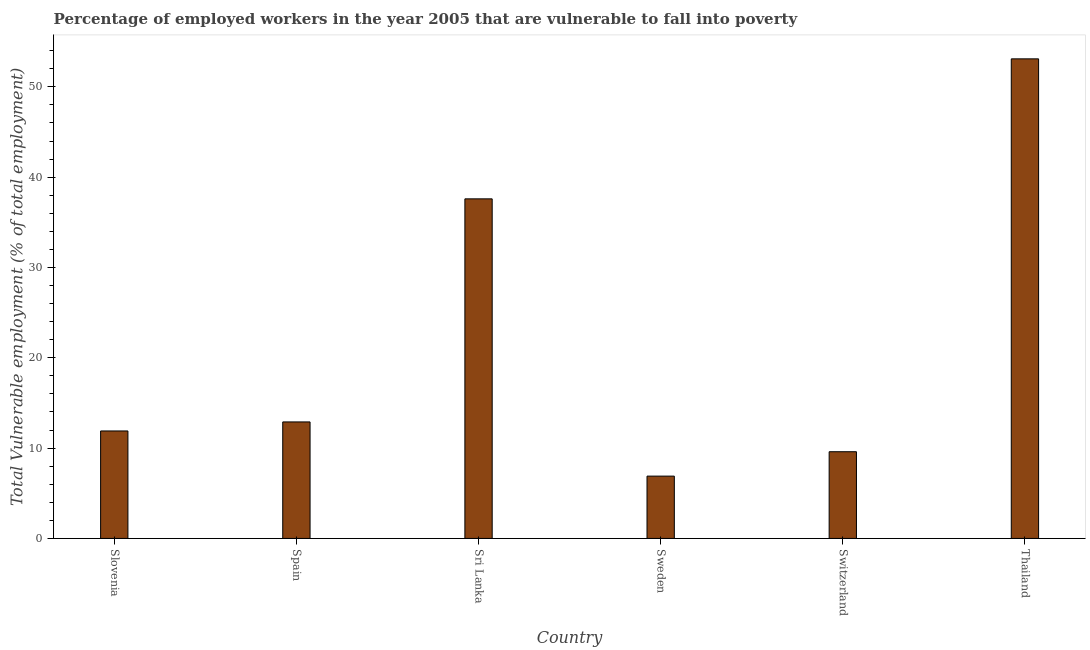Does the graph contain any zero values?
Offer a terse response. No. What is the title of the graph?
Give a very brief answer. Percentage of employed workers in the year 2005 that are vulnerable to fall into poverty. What is the label or title of the X-axis?
Provide a succinct answer. Country. What is the label or title of the Y-axis?
Offer a terse response. Total Vulnerable employment (% of total employment). What is the total vulnerable employment in Sweden?
Your answer should be very brief. 6.9. Across all countries, what is the maximum total vulnerable employment?
Keep it short and to the point. 53.1. Across all countries, what is the minimum total vulnerable employment?
Offer a very short reply. 6.9. In which country was the total vulnerable employment maximum?
Offer a very short reply. Thailand. In which country was the total vulnerable employment minimum?
Make the answer very short. Sweden. What is the sum of the total vulnerable employment?
Make the answer very short. 132. What is the difference between the total vulnerable employment in Slovenia and Spain?
Give a very brief answer. -1. What is the median total vulnerable employment?
Your answer should be very brief. 12.4. In how many countries, is the total vulnerable employment greater than 18 %?
Ensure brevity in your answer.  2. What is the ratio of the total vulnerable employment in Sweden to that in Switzerland?
Give a very brief answer. 0.72. Is the total vulnerable employment in Slovenia less than that in Sri Lanka?
Offer a very short reply. Yes. Is the difference between the total vulnerable employment in Spain and Sweden greater than the difference between any two countries?
Keep it short and to the point. No. Is the sum of the total vulnerable employment in Slovenia and Switzerland greater than the maximum total vulnerable employment across all countries?
Offer a terse response. No. What is the difference between the highest and the lowest total vulnerable employment?
Provide a succinct answer. 46.2. In how many countries, is the total vulnerable employment greater than the average total vulnerable employment taken over all countries?
Keep it short and to the point. 2. How many bars are there?
Give a very brief answer. 6. Are all the bars in the graph horizontal?
Offer a terse response. No. What is the Total Vulnerable employment (% of total employment) in Slovenia?
Give a very brief answer. 11.9. What is the Total Vulnerable employment (% of total employment) in Spain?
Ensure brevity in your answer.  12.9. What is the Total Vulnerable employment (% of total employment) in Sri Lanka?
Provide a succinct answer. 37.6. What is the Total Vulnerable employment (% of total employment) in Sweden?
Your response must be concise. 6.9. What is the Total Vulnerable employment (% of total employment) of Switzerland?
Provide a succinct answer. 9.6. What is the Total Vulnerable employment (% of total employment) of Thailand?
Make the answer very short. 53.1. What is the difference between the Total Vulnerable employment (% of total employment) in Slovenia and Spain?
Your answer should be compact. -1. What is the difference between the Total Vulnerable employment (% of total employment) in Slovenia and Sri Lanka?
Your response must be concise. -25.7. What is the difference between the Total Vulnerable employment (% of total employment) in Slovenia and Switzerland?
Your answer should be compact. 2.3. What is the difference between the Total Vulnerable employment (% of total employment) in Slovenia and Thailand?
Your answer should be compact. -41.2. What is the difference between the Total Vulnerable employment (% of total employment) in Spain and Sri Lanka?
Give a very brief answer. -24.7. What is the difference between the Total Vulnerable employment (% of total employment) in Spain and Sweden?
Offer a terse response. 6. What is the difference between the Total Vulnerable employment (% of total employment) in Spain and Switzerland?
Provide a succinct answer. 3.3. What is the difference between the Total Vulnerable employment (% of total employment) in Spain and Thailand?
Offer a terse response. -40.2. What is the difference between the Total Vulnerable employment (% of total employment) in Sri Lanka and Sweden?
Ensure brevity in your answer.  30.7. What is the difference between the Total Vulnerable employment (% of total employment) in Sri Lanka and Switzerland?
Your answer should be very brief. 28. What is the difference between the Total Vulnerable employment (% of total employment) in Sri Lanka and Thailand?
Your answer should be very brief. -15.5. What is the difference between the Total Vulnerable employment (% of total employment) in Sweden and Thailand?
Make the answer very short. -46.2. What is the difference between the Total Vulnerable employment (% of total employment) in Switzerland and Thailand?
Keep it short and to the point. -43.5. What is the ratio of the Total Vulnerable employment (% of total employment) in Slovenia to that in Spain?
Offer a terse response. 0.92. What is the ratio of the Total Vulnerable employment (% of total employment) in Slovenia to that in Sri Lanka?
Your answer should be very brief. 0.32. What is the ratio of the Total Vulnerable employment (% of total employment) in Slovenia to that in Sweden?
Your answer should be compact. 1.73. What is the ratio of the Total Vulnerable employment (% of total employment) in Slovenia to that in Switzerland?
Your answer should be compact. 1.24. What is the ratio of the Total Vulnerable employment (% of total employment) in Slovenia to that in Thailand?
Your answer should be very brief. 0.22. What is the ratio of the Total Vulnerable employment (% of total employment) in Spain to that in Sri Lanka?
Offer a terse response. 0.34. What is the ratio of the Total Vulnerable employment (% of total employment) in Spain to that in Sweden?
Provide a succinct answer. 1.87. What is the ratio of the Total Vulnerable employment (% of total employment) in Spain to that in Switzerland?
Make the answer very short. 1.34. What is the ratio of the Total Vulnerable employment (% of total employment) in Spain to that in Thailand?
Provide a succinct answer. 0.24. What is the ratio of the Total Vulnerable employment (% of total employment) in Sri Lanka to that in Sweden?
Provide a short and direct response. 5.45. What is the ratio of the Total Vulnerable employment (% of total employment) in Sri Lanka to that in Switzerland?
Offer a terse response. 3.92. What is the ratio of the Total Vulnerable employment (% of total employment) in Sri Lanka to that in Thailand?
Offer a terse response. 0.71. What is the ratio of the Total Vulnerable employment (% of total employment) in Sweden to that in Switzerland?
Your answer should be very brief. 0.72. What is the ratio of the Total Vulnerable employment (% of total employment) in Sweden to that in Thailand?
Your answer should be very brief. 0.13. What is the ratio of the Total Vulnerable employment (% of total employment) in Switzerland to that in Thailand?
Make the answer very short. 0.18. 